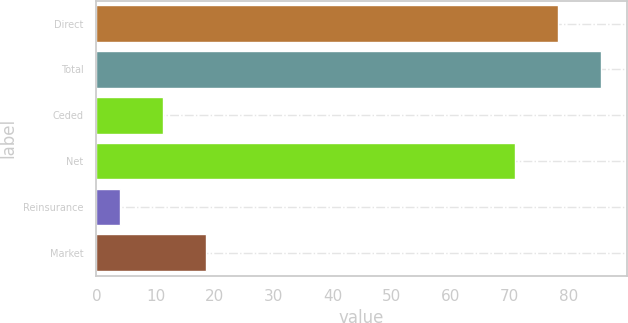<chart> <loc_0><loc_0><loc_500><loc_500><bar_chart><fcel>Direct<fcel>Total<fcel>Ceded<fcel>Net<fcel>Reinsurance<fcel>Market<nl><fcel>78.3<fcel>85.6<fcel>11.3<fcel>71<fcel>4<fcel>18.6<nl></chart> 